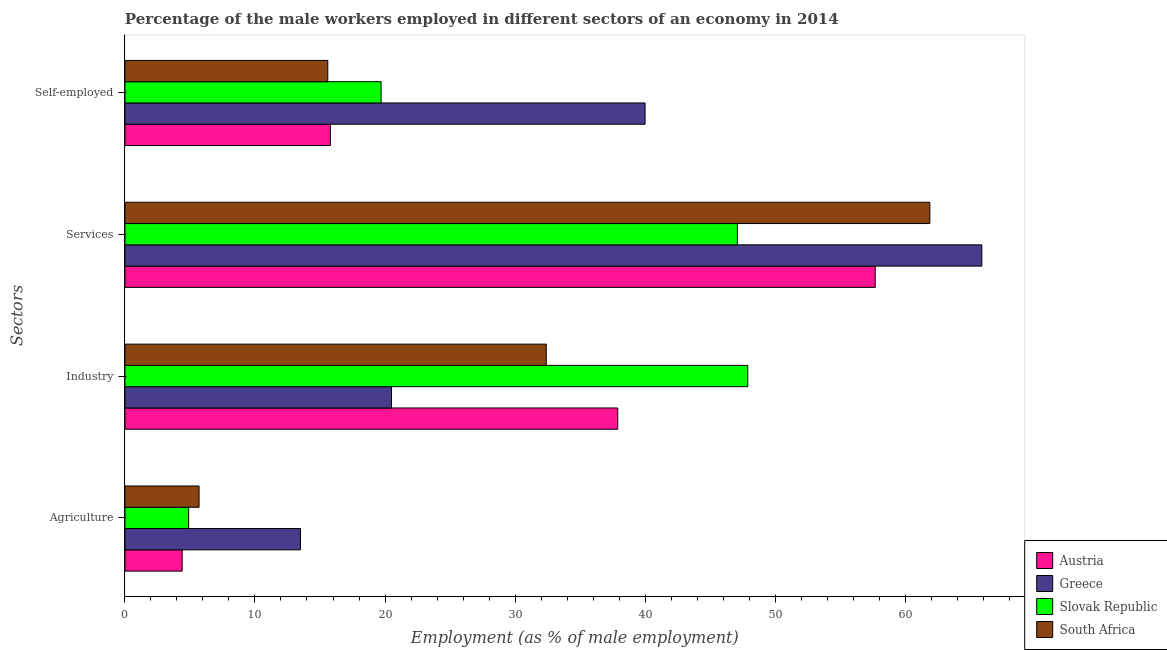How many different coloured bars are there?
Offer a terse response. 4. How many groups of bars are there?
Your answer should be compact. 4. Are the number of bars on each tick of the Y-axis equal?
Offer a very short reply. Yes. How many bars are there on the 1st tick from the top?
Provide a short and direct response. 4. What is the label of the 2nd group of bars from the top?
Give a very brief answer. Services. What is the percentage of self employed male workers in Slovak Republic?
Your answer should be very brief. 19.7. Across all countries, what is the maximum percentage of male workers in industry?
Ensure brevity in your answer.  47.9. Across all countries, what is the minimum percentage of male workers in services?
Keep it short and to the point. 47.1. In which country was the percentage of self employed male workers minimum?
Your answer should be compact. South Africa. What is the total percentage of male workers in industry in the graph?
Your answer should be compact. 138.7. What is the difference between the percentage of male workers in agriculture in South Africa and that in Greece?
Offer a terse response. -7.8. What is the difference between the percentage of male workers in industry in Austria and the percentage of male workers in agriculture in Greece?
Your answer should be very brief. 24.4. What is the average percentage of male workers in agriculture per country?
Make the answer very short. 7.13. What is the difference between the percentage of self employed male workers and percentage of male workers in industry in South Africa?
Provide a succinct answer. -16.8. In how many countries, is the percentage of self employed male workers greater than 40 %?
Your answer should be very brief. 0. What is the ratio of the percentage of self employed male workers in Austria to that in Greece?
Offer a very short reply. 0.4. Is the percentage of male workers in agriculture in Greece less than that in Slovak Republic?
Offer a terse response. No. Is the difference between the percentage of self employed male workers in Slovak Republic and Austria greater than the difference between the percentage of male workers in industry in Slovak Republic and Austria?
Your answer should be compact. No. What is the difference between the highest and the second highest percentage of male workers in agriculture?
Provide a short and direct response. 7.8. What is the difference between the highest and the lowest percentage of male workers in industry?
Provide a succinct answer. 27.4. Is the sum of the percentage of male workers in industry in Slovak Republic and Austria greater than the maximum percentage of self employed male workers across all countries?
Your answer should be compact. Yes. Is it the case that in every country, the sum of the percentage of male workers in industry and percentage of male workers in services is greater than the sum of percentage of self employed male workers and percentage of male workers in agriculture?
Make the answer very short. Yes. What does the 4th bar from the bottom in Agriculture represents?
Offer a terse response. South Africa. Is it the case that in every country, the sum of the percentage of male workers in agriculture and percentage of male workers in industry is greater than the percentage of male workers in services?
Give a very brief answer. No. Does the graph contain any zero values?
Give a very brief answer. No. Does the graph contain grids?
Your answer should be very brief. No. Where does the legend appear in the graph?
Keep it short and to the point. Bottom right. How many legend labels are there?
Your answer should be compact. 4. What is the title of the graph?
Provide a succinct answer. Percentage of the male workers employed in different sectors of an economy in 2014. Does "Uzbekistan" appear as one of the legend labels in the graph?
Make the answer very short. No. What is the label or title of the X-axis?
Offer a very short reply. Employment (as % of male employment). What is the label or title of the Y-axis?
Your answer should be compact. Sectors. What is the Employment (as % of male employment) in Austria in Agriculture?
Provide a short and direct response. 4.4. What is the Employment (as % of male employment) in Greece in Agriculture?
Keep it short and to the point. 13.5. What is the Employment (as % of male employment) in Slovak Republic in Agriculture?
Offer a terse response. 4.9. What is the Employment (as % of male employment) of South Africa in Agriculture?
Make the answer very short. 5.7. What is the Employment (as % of male employment) of Austria in Industry?
Give a very brief answer. 37.9. What is the Employment (as % of male employment) of Slovak Republic in Industry?
Your answer should be compact. 47.9. What is the Employment (as % of male employment) of South Africa in Industry?
Your answer should be compact. 32.4. What is the Employment (as % of male employment) in Austria in Services?
Keep it short and to the point. 57.7. What is the Employment (as % of male employment) in Greece in Services?
Make the answer very short. 65.9. What is the Employment (as % of male employment) of Slovak Republic in Services?
Make the answer very short. 47.1. What is the Employment (as % of male employment) in South Africa in Services?
Give a very brief answer. 61.9. What is the Employment (as % of male employment) of Austria in Self-employed?
Your answer should be very brief. 15.8. What is the Employment (as % of male employment) of Slovak Republic in Self-employed?
Offer a terse response. 19.7. What is the Employment (as % of male employment) in South Africa in Self-employed?
Make the answer very short. 15.6. Across all Sectors, what is the maximum Employment (as % of male employment) of Austria?
Offer a terse response. 57.7. Across all Sectors, what is the maximum Employment (as % of male employment) in Greece?
Give a very brief answer. 65.9. Across all Sectors, what is the maximum Employment (as % of male employment) in Slovak Republic?
Offer a terse response. 47.9. Across all Sectors, what is the maximum Employment (as % of male employment) of South Africa?
Your response must be concise. 61.9. Across all Sectors, what is the minimum Employment (as % of male employment) in Austria?
Your response must be concise. 4.4. Across all Sectors, what is the minimum Employment (as % of male employment) in Slovak Republic?
Your answer should be compact. 4.9. Across all Sectors, what is the minimum Employment (as % of male employment) in South Africa?
Make the answer very short. 5.7. What is the total Employment (as % of male employment) in Austria in the graph?
Offer a terse response. 115.8. What is the total Employment (as % of male employment) in Greece in the graph?
Your answer should be compact. 139.9. What is the total Employment (as % of male employment) in Slovak Republic in the graph?
Keep it short and to the point. 119.6. What is the total Employment (as % of male employment) in South Africa in the graph?
Your answer should be very brief. 115.6. What is the difference between the Employment (as % of male employment) in Austria in Agriculture and that in Industry?
Make the answer very short. -33.5. What is the difference between the Employment (as % of male employment) in Slovak Republic in Agriculture and that in Industry?
Make the answer very short. -43. What is the difference between the Employment (as % of male employment) in South Africa in Agriculture and that in Industry?
Offer a terse response. -26.7. What is the difference between the Employment (as % of male employment) of Austria in Agriculture and that in Services?
Provide a short and direct response. -53.3. What is the difference between the Employment (as % of male employment) in Greece in Agriculture and that in Services?
Ensure brevity in your answer.  -52.4. What is the difference between the Employment (as % of male employment) in Slovak Republic in Agriculture and that in Services?
Provide a short and direct response. -42.2. What is the difference between the Employment (as % of male employment) of South Africa in Agriculture and that in Services?
Provide a short and direct response. -56.2. What is the difference between the Employment (as % of male employment) of Austria in Agriculture and that in Self-employed?
Your answer should be very brief. -11.4. What is the difference between the Employment (as % of male employment) in Greece in Agriculture and that in Self-employed?
Offer a very short reply. -26.5. What is the difference between the Employment (as % of male employment) of Slovak Republic in Agriculture and that in Self-employed?
Your response must be concise. -14.8. What is the difference between the Employment (as % of male employment) in South Africa in Agriculture and that in Self-employed?
Provide a short and direct response. -9.9. What is the difference between the Employment (as % of male employment) of Austria in Industry and that in Services?
Your answer should be very brief. -19.8. What is the difference between the Employment (as % of male employment) in Greece in Industry and that in Services?
Keep it short and to the point. -45.4. What is the difference between the Employment (as % of male employment) of Slovak Republic in Industry and that in Services?
Offer a very short reply. 0.8. What is the difference between the Employment (as % of male employment) in South Africa in Industry and that in Services?
Provide a short and direct response. -29.5. What is the difference between the Employment (as % of male employment) of Austria in Industry and that in Self-employed?
Make the answer very short. 22.1. What is the difference between the Employment (as % of male employment) in Greece in Industry and that in Self-employed?
Provide a succinct answer. -19.5. What is the difference between the Employment (as % of male employment) of Slovak Republic in Industry and that in Self-employed?
Offer a very short reply. 28.2. What is the difference between the Employment (as % of male employment) in South Africa in Industry and that in Self-employed?
Ensure brevity in your answer.  16.8. What is the difference between the Employment (as % of male employment) in Austria in Services and that in Self-employed?
Your response must be concise. 41.9. What is the difference between the Employment (as % of male employment) of Greece in Services and that in Self-employed?
Give a very brief answer. 25.9. What is the difference between the Employment (as % of male employment) of Slovak Republic in Services and that in Self-employed?
Give a very brief answer. 27.4. What is the difference between the Employment (as % of male employment) in South Africa in Services and that in Self-employed?
Ensure brevity in your answer.  46.3. What is the difference between the Employment (as % of male employment) in Austria in Agriculture and the Employment (as % of male employment) in Greece in Industry?
Offer a terse response. -16.1. What is the difference between the Employment (as % of male employment) in Austria in Agriculture and the Employment (as % of male employment) in Slovak Republic in Industry?
Your answer should be very brief. -43.5. What is the difference between the Employment (as % of male employment) of Greece in Agriculture and the Employment (as % of male employment) of Slovak Republic in Industry?
Offer a terse response. -34.4. What is the difference between the Employment (as % of male employment) in Greece in Agriculture and the Employment (as % of male employment) in South Africa in Industry?
Make the answer very short. -18.9. What is the difference between the Employment (as % of male employment) in Slovak Republic in Agriculture and the Employment (as % of male employment) in South Africa in Industry?
Provide a short and direct response. -27.5. What is the difference between the Employment (as % of male employment) of Austria in Agriculture and the Employment (as % of male employment) of Greece in Services?
Give a very brief answer. -61.5. What is the difference between the Employment (as % of male employment) of Austria in Agriculture and the Employment (as % of male employment) of Slovak Republic in Services?
Offer a very short reply. -42.7. What is the difference between the Employment (as % of male employment) in Austria in Agriculture and the Employment (as % of male employment) in South Africa in Services?
Ensure brevity in your answer.  -57.5. What is the difference between the Employment (as % of male employment) of Greece in Agriculture and the Employment (as % of male employment) of Slovak Republic in Services?
Give a very brief answer. -33.6. What is the difference between the Employment (as % of male employment) in Greece in Agriculture and the Employment (as % of male employment) in South Africa in Services?
Provide a succinct answer. -48.4. What is the difference between the Employment (as % of male employment) of Slovak Republic in Agriculture and the Employment (as % of male employment) of South Africa in Services?
Give a very brief answer. -57. What is the difference between the Employment (as % of male employment) of Austria in Agriculture and the Employment (as % of male employment) of Greece in Self-employed?
Keep it short and to the point. -35.6. What is the difference between the Employment (as % of male employment) of Austria in Agriculture and the Employment (as % of male employment) of Slovak Republic in Self-employed?
Provide a short and direct response. -15.3. What is the difference between the Employment (as % of male employment) of Austria in Industry and the Employment (as % of male employment) of South Africa in Services?
Offer a terse response. -24. What is the difference between the Employment (as % of male employment) in Greece in Industry and the Employment (as % of male employment) in Slovak Republic in Services?
Provide a short and direct response. -26.6. What is the difference between the Employment (as % of male employment) of Greece in Industry and the Employment (as % of male employment) of South Africa in Services?
Provide a succinct answer. -41.4. What is the difference between the Employment (as % of male employment) of Austria in Industry and the Employment (as % of male employment) of South Africa in Self-employed?
Provide a succinct answer. 22.3. What is the difference between the Employment (as % of male employment) of Greece in Industry and the Employment (as % of male employment) of South Africa in Self-employed?
Your answer should be compact. 4.9. What is the difference between the Employment (as % of male employment) of Slovak Republic in Industry and the Employment (as % of male employment) of South Africa in Self-employed?
Ensure brevity in your answer.  32.3. What is the difference between the Employment (as % of male employment) in Austria in Services and the Employment (as % of male employment) in Greece in Self-employed?
Keep it short and to the point. 17.7. What is the difference between the Employment (as % of male employment) of Austria in Services and the Employment (as % of male employment) of South Africa in Self-employed?
Your answer should be compact. 42.1. What is the difference between the Employment (as % of male employment) in Greece in Services and the Employment (as % of male employment) in Slovak Republic in Self-employed?
Offer a terse response. 46.2. What is the difference between the Employment (as % of male employment) in Greece in Services and the Employment (as % of male employment) in South Africa in Self-employed?
Make the answer very short. 50.3. What is the difference between the Employment (as % of male employment) in Slovak Republic in Services and the Employment (as % of male employment) in South Africa in Self-employed?
Make the answer very short. 31.5. What is the average Employment (as % of male employment) of Austria per Sectors?
Provide a short and direct response. 28.95. What is the average Employment (as % of male employment) in Greece per Sectors?
Provide a succinct answer. 34.98. What is the average Employment (as % of male employment) in Slovak Republic per Sectors?
Your response must be concise. 29.9. What is the average Employment (as % of male employment) in South Africa per Sectors?
Provide a succinct answer. 28.9. What is the difference between the Employment (as % of male employment) of Austria and Employment (as % of male employment) of South Africa in Agriculture?
Provide a succinct answer. -1.3. What is the difference between the Employment (as % of male employment) in Austria and Employment (as % of male employment) in Greece in Industry?
Provide a succinct answer. 17.4. What is the difference between the Employment (as % of male employment) of Austria and Employment (as % of male employment) of Slovak Republic in Industry?
Ensure brevity in your answer.  -10. What is the difference between the Employment (as % of male employment) of Greece and Employment (as % of male employment) of Slovak Republic in Industry?
Your answer should be compact. -27.4. What is the difference between the Employment (as % of male employment) in Greece and Employment (as % of male employment) in South Africa in Industry?
Offer a very short reply. -11.9. What is the difference between the Employment (as % of male employment) of Austria and Employment (as % of male employment) of Greece in Services?
Provide a succinct answer. -8.2. What is the difference between the Employment (as % of male employment) in Greece and Employment (as % of male employment) in South Africa in Services?
Ensure brevity in your answer.  4. What is the difference between the Employment (as % of male employment) of Slovak Republic and Employment (as % of male employment) of South Africa in Services?
Your answer should be very brief. -14.8. What is the difference between the Employment (as % of male employment) of Austria and Employment (as % of male employment) of Greece in Self-employed?
Offer a very short reply. -24.2. What is the difference between the Employment (as % of male employment) of Greece and Employment (as % of male employment) of Slovak Republic in Self-employed?
Offer a very short reply. 20.3. What is the difference between the Employment (as % of male employment) in Greece and Employment (as % of male employment) in South Africa in Self-employed?
Your response must be concise. 24.4. What is the ratio of the Employment (as % of male employment) of Austria in Agriculture to that in Industry?
Ensure brevity in your answer.  0.12. What is the ratio of the Employment (as % of male employment) of Greece in Agriculture to that in Industry?
Ensure brevity in your answer.  0.66. What is the ratio of the Employment (as % of male employment) of Slovak Republic in Agriculture to that in Industry?
Offer a terse response. 0.1. What is the ratio of the Employment (as % of male employment) in South Africa in Agriculture to that in Industry?
Offer a very short reply. 0.18. What is the ratio of the Employment (as % of male employment) of Austria in Agriculture to that in Services?
Your response must be concise. 0.08. What is the ratio of the Employment (as % of male employment) in Greece in Agriculture to that in Services?
Make the answer very short. 0.2. What is the ratio of the Employment (as % of male employment) of Slovak Republic in Agriculture to that in Services?
Provide a succinct answer. 0.1. What is the ratio of the Employment (as % of male employment) of South Africa in Agriculture to that in Services?
Ensure brevity in your answer.  0.09. What is the ratio of the Employment (as % of male employment) of Austria in Agriculture to that in Self-employed?
Your answer should be very brief. 0.28. What is the ratio of the Employment (as % of male employment) of Greece in Agriculture to that in Self-employed?
Your response must be concise. 0.34. What is the ratio of the Employment (as % of male employment) in Slovak Republic in Agriculture to that in Self-employed?
Your answer should be compact. 0.25. What is the ratio of the Employment (as % of male employment) in South Africa in Agriculture to that in Self-employed?
Offer a terse response. 0.37. What is the ratio of the Employment (as % of male employment) in Austria in Industry to that in Services?
Your response must be concise. 0.66. What is the ratio of the Employment (as % of male employment) of Greece in Industry to that in Services?
Offer a very short reply. 0.31. What is the ratio of the Employment (as % of male employment) in South Africa in Industry to that in Services?
Make the answer very short. 0.52. What is the ratio of the Employment (as % of male employment) of Austria in Industry to that in Self-employed?
Your answer should be very brief. 2.4. What is the ratio of the Employment (as % of male employment) in Greece in Industry to that in Self-employed?
Your answer should be very brief. 0.51. What is the ratio of the Employment (as % of male employment) in Slovak Republic in Industry to that in Self-employed?
Provide a succinct answer. 2.43. What is the ratio of the Employment (as % of male employment) in South Africa in Industry to that in Self-employed?
Your response must be concise. 2.08. What is the ratio of the Employment (as % of male employment) in Austria in Services to that in Self-employed?
Offer a very short reply. 3.65. What is the ratio of the Employment (as % of male employment) in Greece in Services to that in Self-employed?
Provide a succinct answer. 1.65. What is the ratio of the Employment (as % of male employment) in Slovak Republic in Services to that in Self-employed?
Make the answer very short. 2.39. What is the ratio of the Employment (as % of male employment) of South Africa in Services to that in Self-employed?
Your answer should be very brief. 3.97. What is the difference between the highest and the second highest Employment (as % of male employment) in Austria?
Your response must be concise. 19.8. What is the difference between the highest and the second highest Employment (as % of male employment) of Greece?
Your answer should be very brief. 25.9. What is the difference between the highest and the second highest Employment (as % of male employment) in Slovak Republic?
Your answer should be very brief. 0.8. What is the difference between the highest and the second highest Employment (as % of male employment) of South Africa?
Make the answer very short. 29.5. What is the difference between the highest and the lowest Employment (as % of male employment) in Austria?
Make the answer very short. 53.3. What is the difference between the highest and the lowest Employment (as % of male employment) in Greece?
Your response must be concise. 52.4. What is the difference between the highest and the lowest Employment (as % of male employment) of South Africa?
Your answer should be very brief. 56.2. 